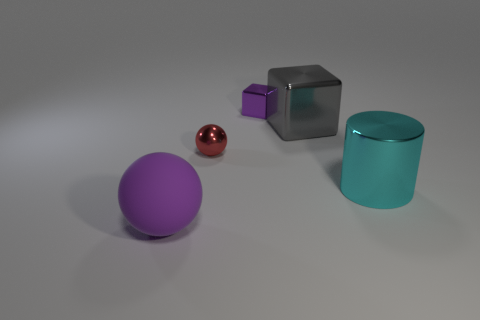Add 4 small purple metallic cubes. How many objects exist? 9 Subtract all cubes. How many objects are left? 3 Subtract all cyan metallic cylinders. Subtract all gray metal cubes. How many objects are left? 3 Add 1 large gray metallic cubes. How many large gray metallic cubes are left? 2 Add 1 large cyan shiny objects. How many large cyan shiny objects exist? 2 Subtract 0 brown cylinders. How many objects are left? 5 